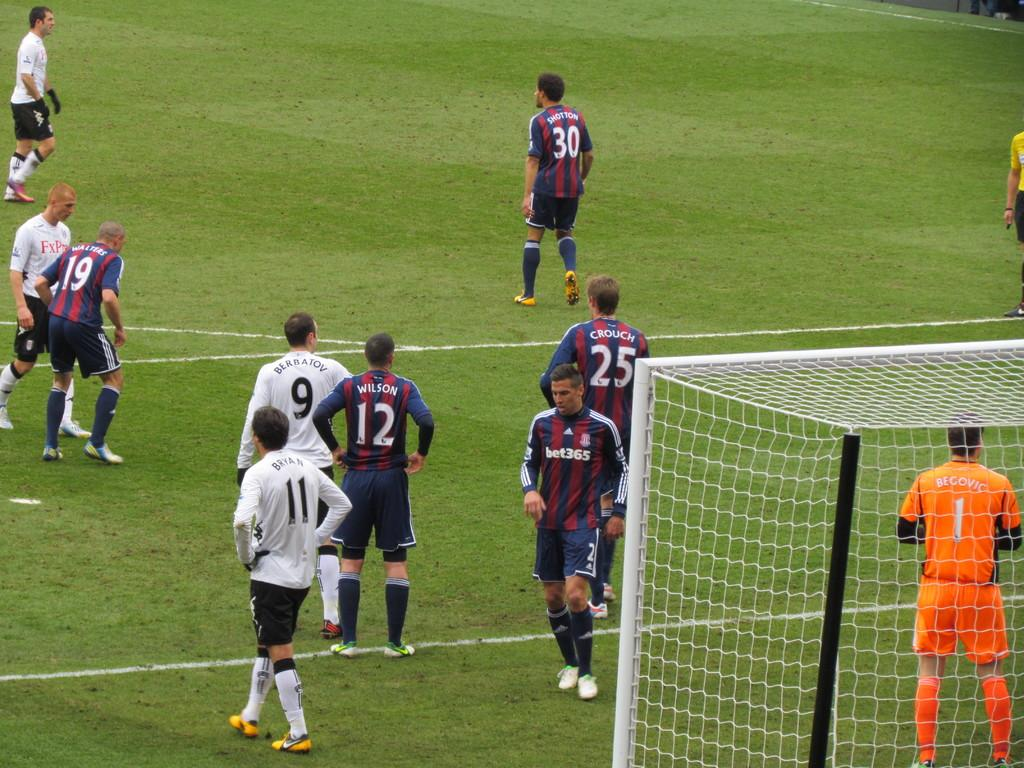How many people are in the image? There is a group of people in the image, but the exact number is not specified. What are some of the people in the image doing? Some people are standing, and some are walking on the grass. What objects can be seen in the image? There are metal rods and a net in the image. What type of stitch is being used to repair the net in the image? There is no indication in the image that the net is being repaired, nor is there any mention of stitching. 